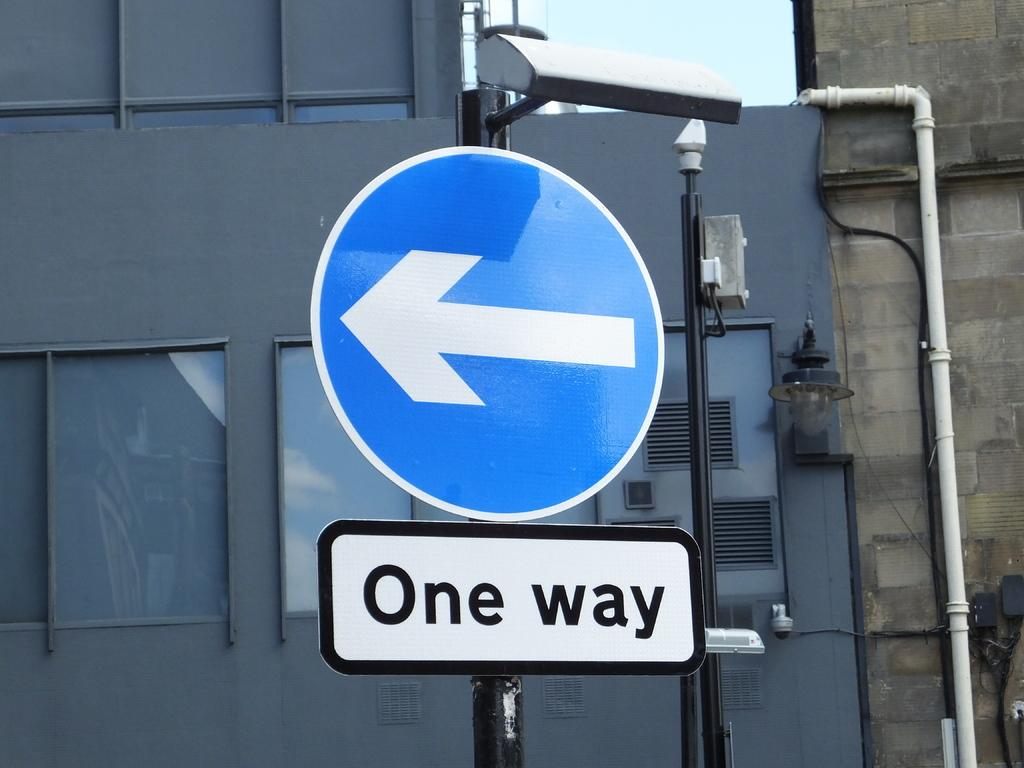<image>
Present a compact description of the photo's key features. A blue circular sign pointing to the left that saway one way under it. 